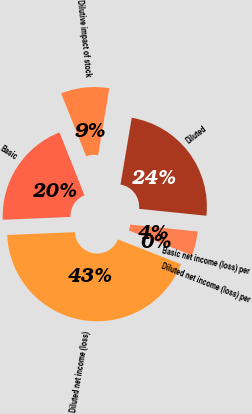<chart> <loc_0><loc_0><loc_500><loc_500><pie_chart><fcel>Diluted net income (loss)<fcel>Basic<fcel>Dilutive impact of stock<fcel>Diluted<fcel>Basic net income (loss) per<fcel>Diluted net income (loss) per<nl><fcel>43.37%<fcel>19.64%<fcel>8.67%<fcel>23.98%<fcel>4.34%<fcel>0.0%<nl></chart> 